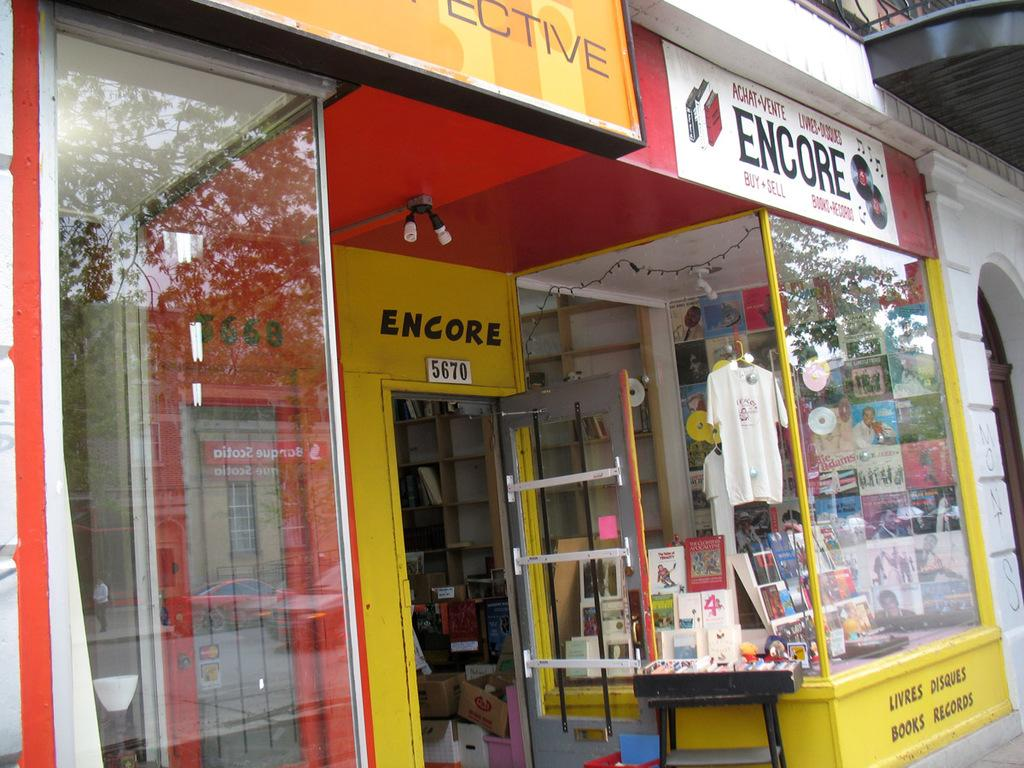Provide a one-sentence caption for the provided image. A record and book store called Encore which is at 5670. 